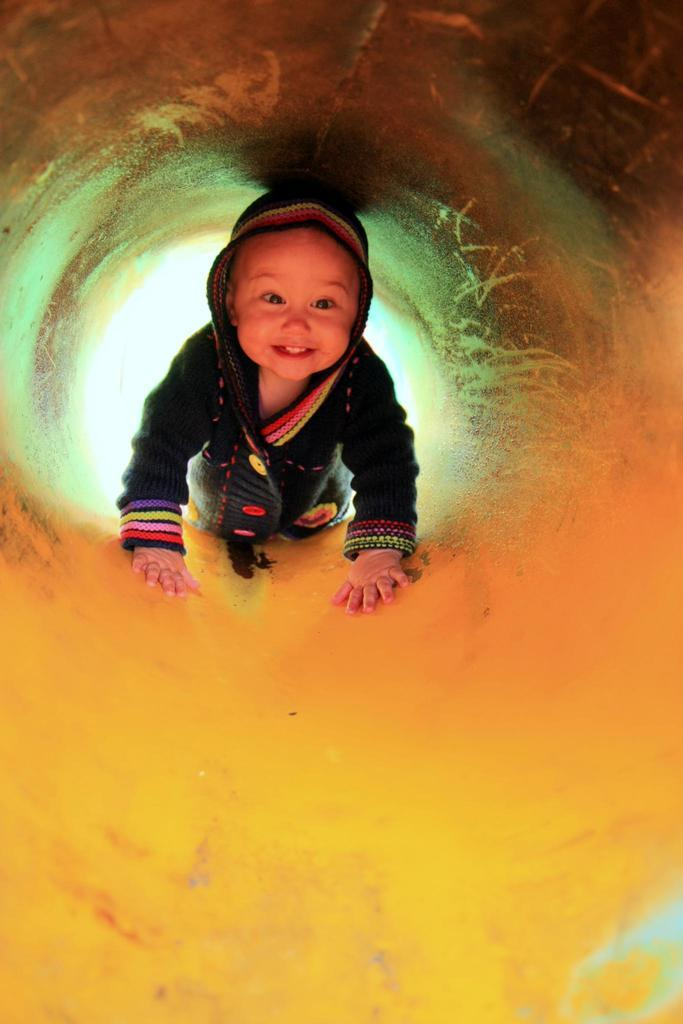What is the main subject of the image? The main subject of the image is a child. What is the child standing or sitting on in the image? The child is on a yellow surface. What is the name of the child in the image? The name of the child is not mentioned or visible in the image, so it cannot be determined. Can you see any cobwebs or flies in the image? There is no mention or indication of cobwebs or flies in the image. 